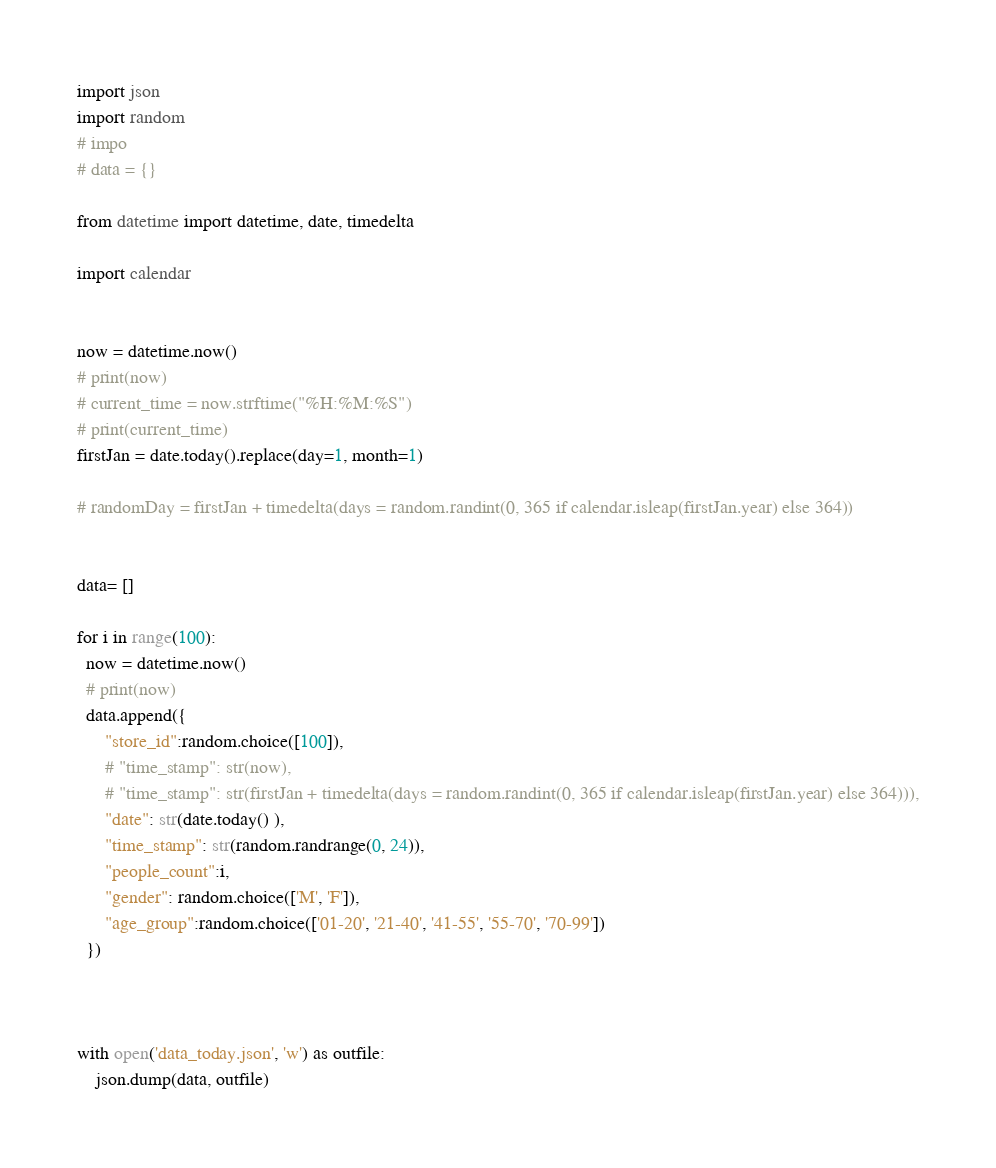Convert code to text. <code><loc_0><loc_0><loc_500><loc_500><_Python_>import json
import random 
# impo
# data = {}

from datetime import datetime, date, timedelta

import calendar


now = datetime.now()
# print(now)
# current_time = now.strftime("%H:%M:%S")
# print(current_time)
firstJan = date.today().replace(day=1, month=1) 

# randomDay = firstJan + timedelta(days = random.randint(0, 365 if calendar.isleap(firstJan.year) else 364))


data= []

for i in range(100):
  now = datetime.now()
  # print(now)
  data.append({
      "store_id":random.choice([100]),
      # "time_stamp": str(now),
      # "time_stamp": str(firstJan + timedelta(days = random.randint(0, 365 if calendar.isleap(firstJan.year) else 364))),
      "date": str(date.today() ),
      "time_stamp": str(random.randrange(0, 24)),
      "people_count":i,
      "gender": random.choice(['M', 'F']),
      "age_group":random.choice(['01-20', '21-40', '41-55', '55-70', '70-99'])
  })



with open('data_today.json', 'w') as outfile:
    json.dump(data, outfile)</code> 